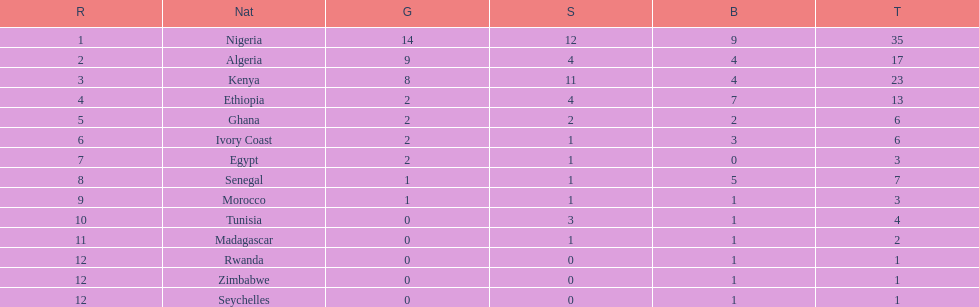How many medals did senegal win? 7. 